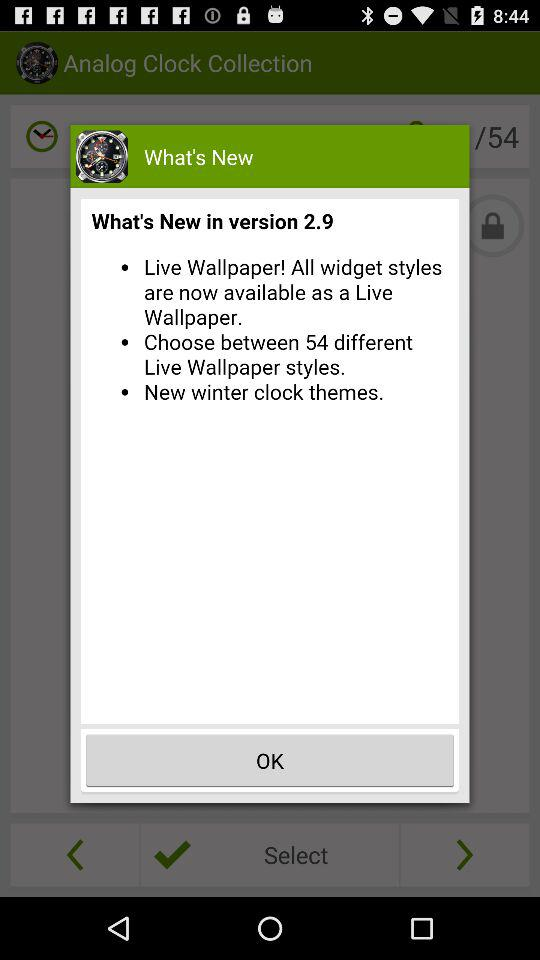What's the new clock theme in version 2.9? The new clock theme in version 2.9 is "winter". 